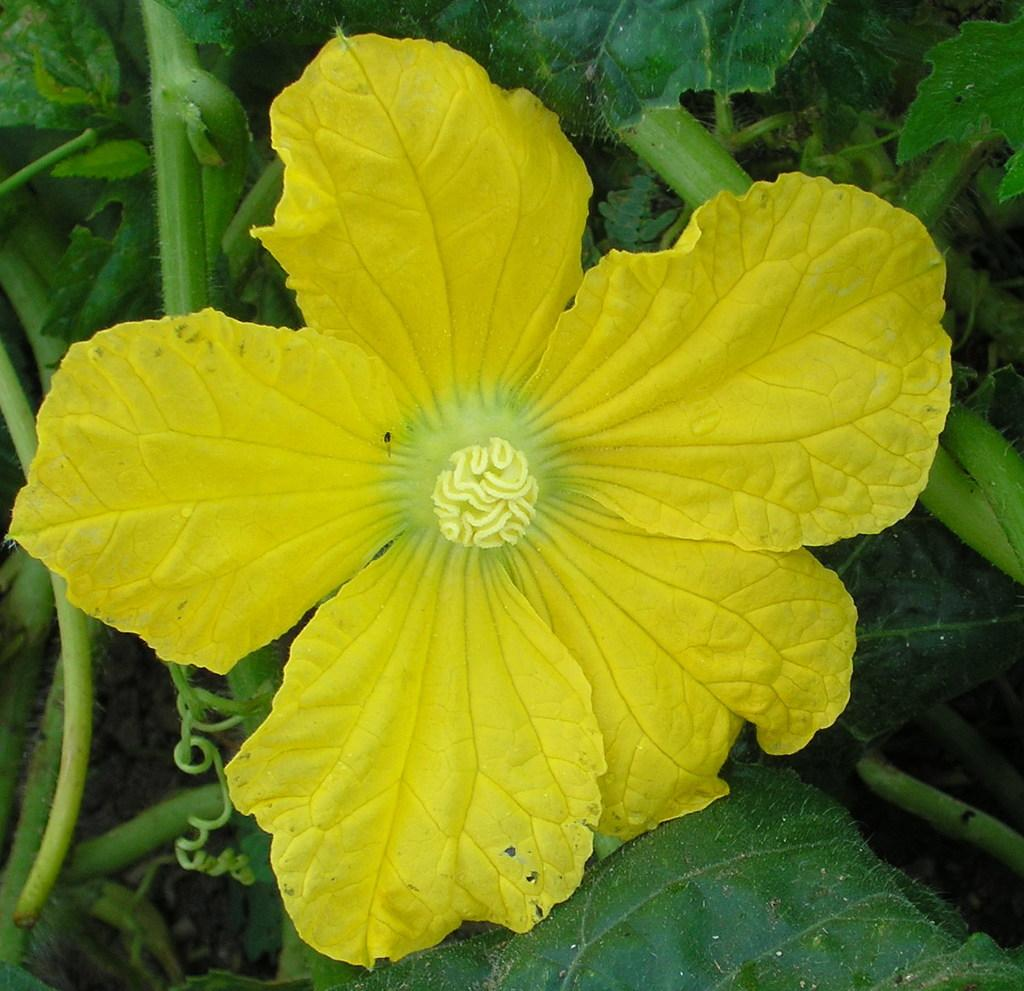What is the main subject of the image? There is a flower in the center of the image. What can be seen in the background of the image? There are leaves and stems in the background of the image. What type of house is visible in the background of the image? There is no house present in the image; it features a flower with leaves and stems in the background. How many divisions can be seen in the cactus in the image? There is no cactus present in the image; it features a flower with leaves and stems in the background. 